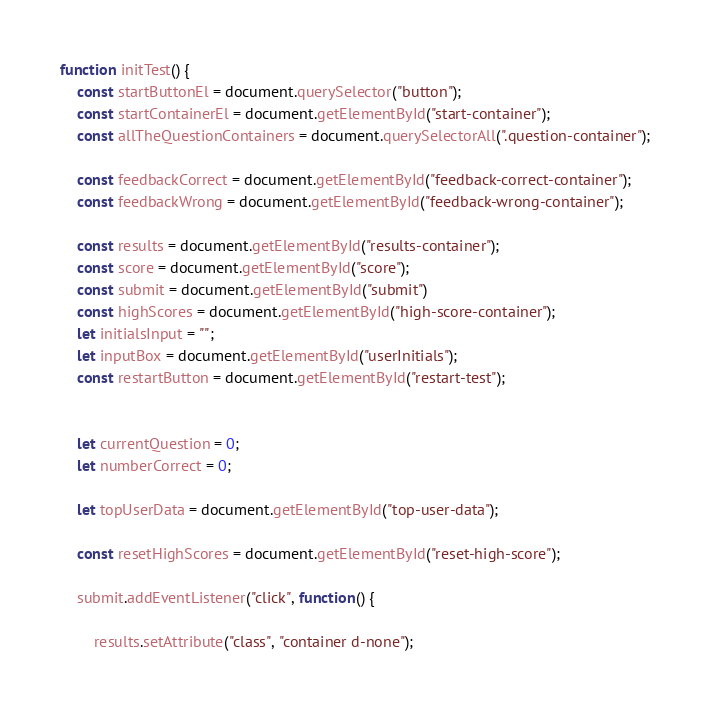<code> <loc_0><loc_0><loc_500><loc_500><_JavaScript_>function initTest() {
    const startButtonEl = document.querySelector("button");
    const startContainerEl = document.getElementById("start-container");
    const allTheQuestionContainers = document.querySelectorAll(".question-container");

    const feedbackCorrect = document.getElementById("feedback-correct-container");
    const feedbackWrong = document.getElementById("feedback-wrong-container");

    const results = document.getElementById("results-container");
    const score = document.getElementById("score");
    const submit = document.getElementById("submit")
    const highScores = document.getElementById("high-score-container");
    let initialsInput = "";
    let inputBox = document.getElementById("userInitials");
    const restartButton = document.getElementById("restart-test");


    let currentQuestion = 0;
    let numberCorrect = 0;

    let topUserData = document.getElementById("top-user-data");

    const resetHighScores = document.getElementById("reset-high-score");

    submit.addEventListener("click", function() {

        results.setAttribute("class", "container d-none");</code> 